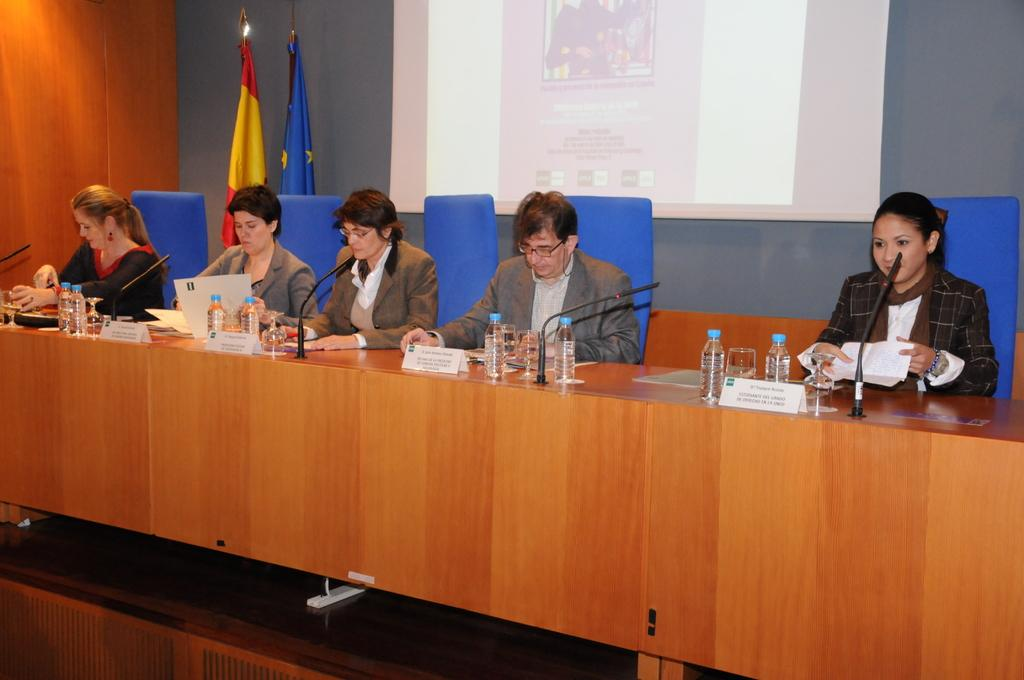What are the people in the image doing? The people in the image are seated on chairs. What items can be seen on the table in the image? There are water bottles, glasses, and microphones on the table. What can be seen on the side of the image? There are two flags on the side of the image. How many girls are present in the image? The provided facts do not mention the gender of the people in the image, so it cannot be determined if there are any girls present. 